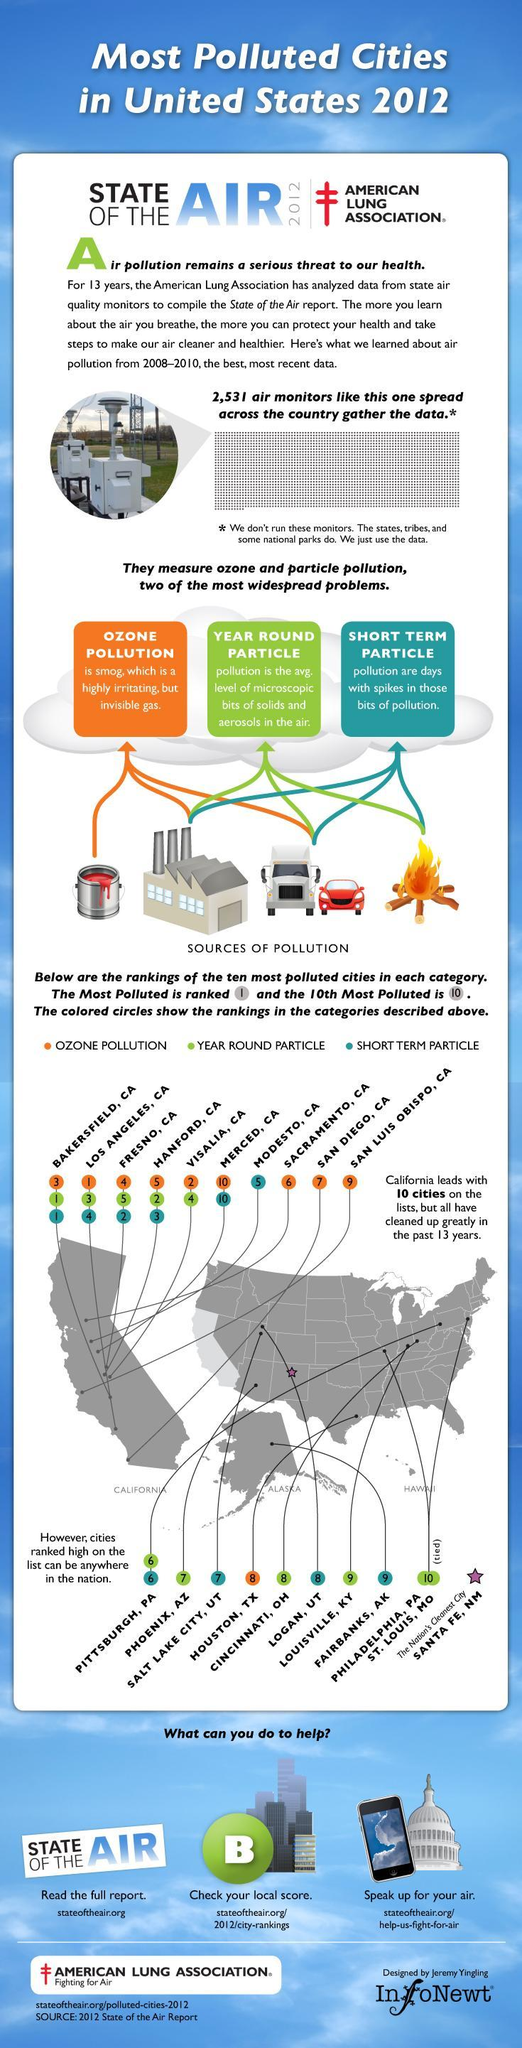Which is the highly irritating and invisible gas mentioned?
Answer the question with a short phrase. smog 